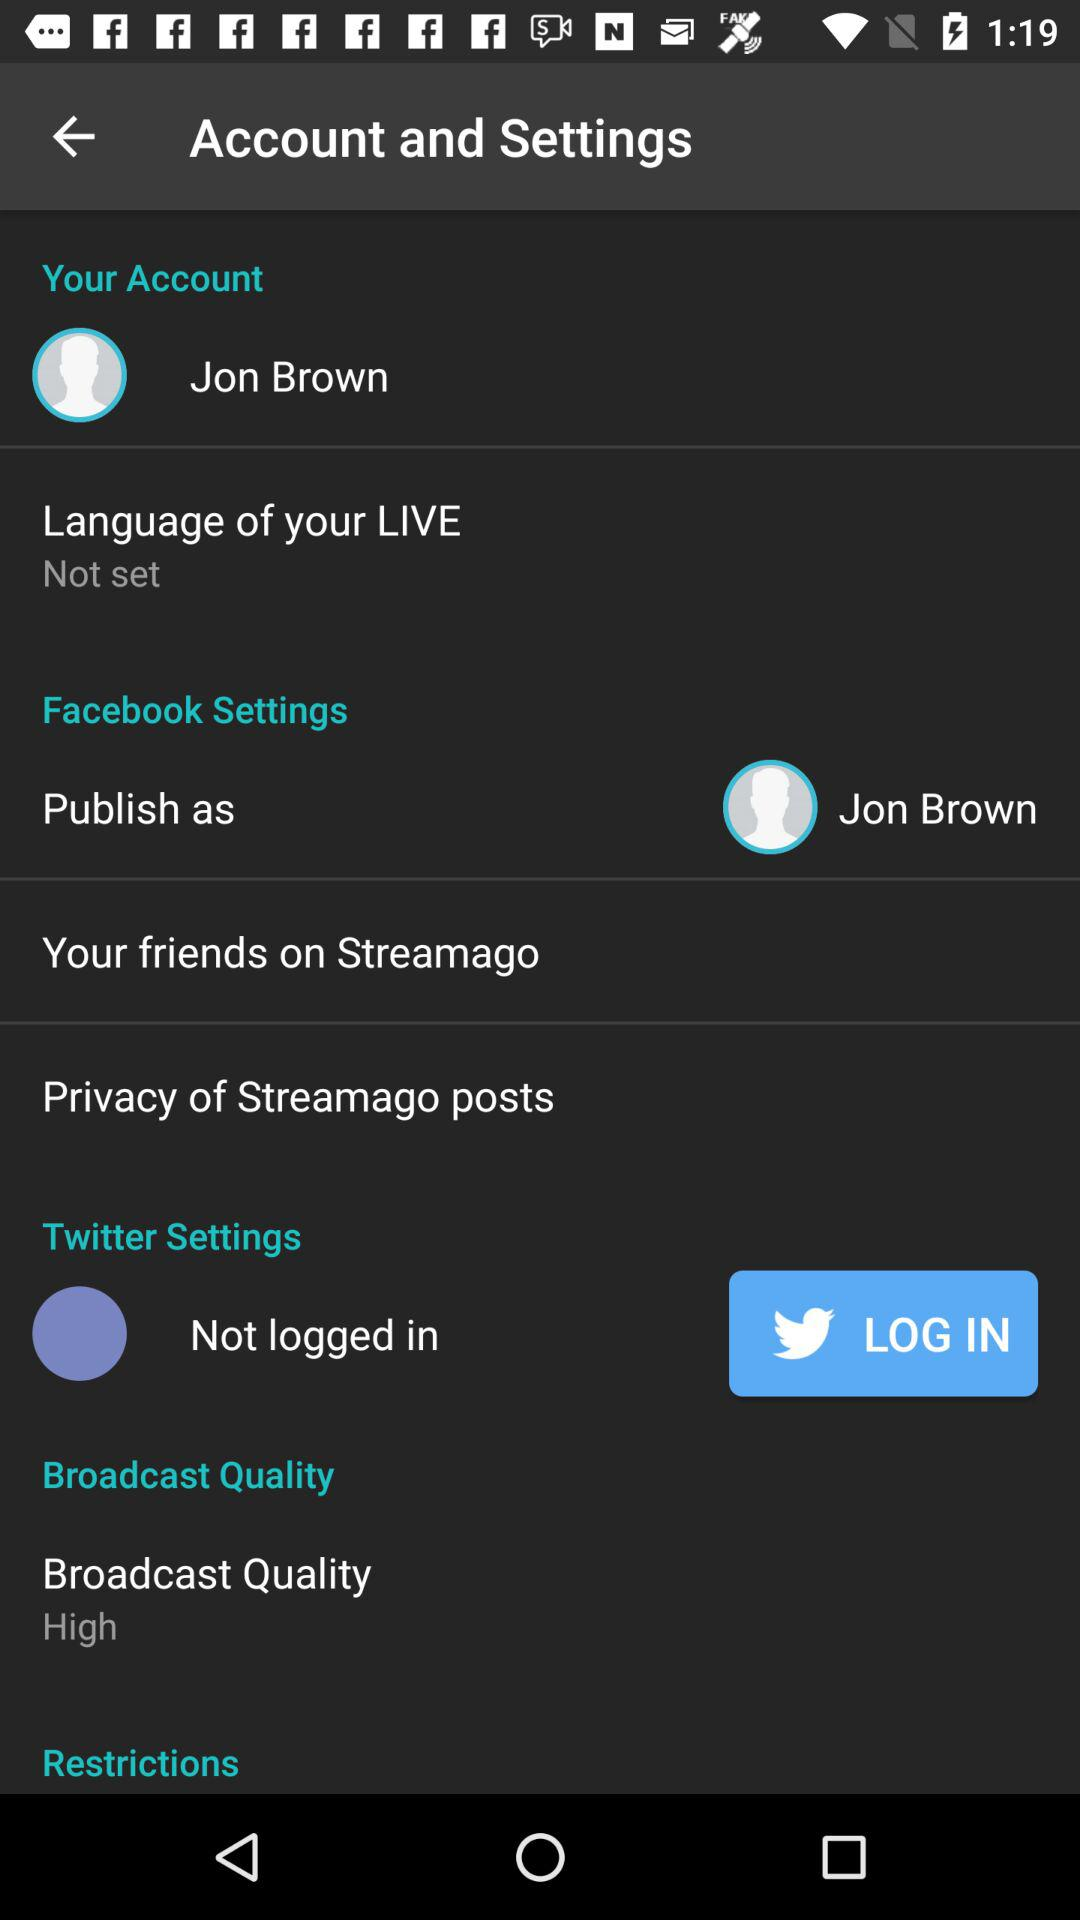What is the given profile name? The profile name is Jon Brown. 